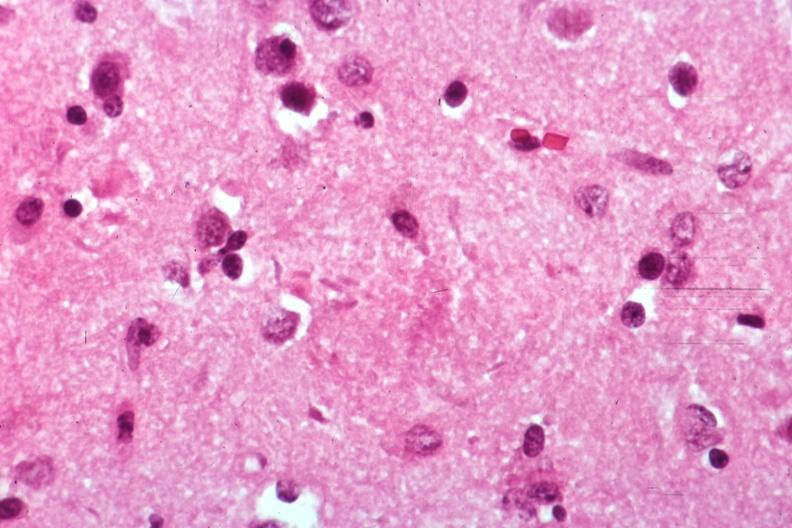what does this image show?
Answer the question using a single word or phrase. Neural tangle 